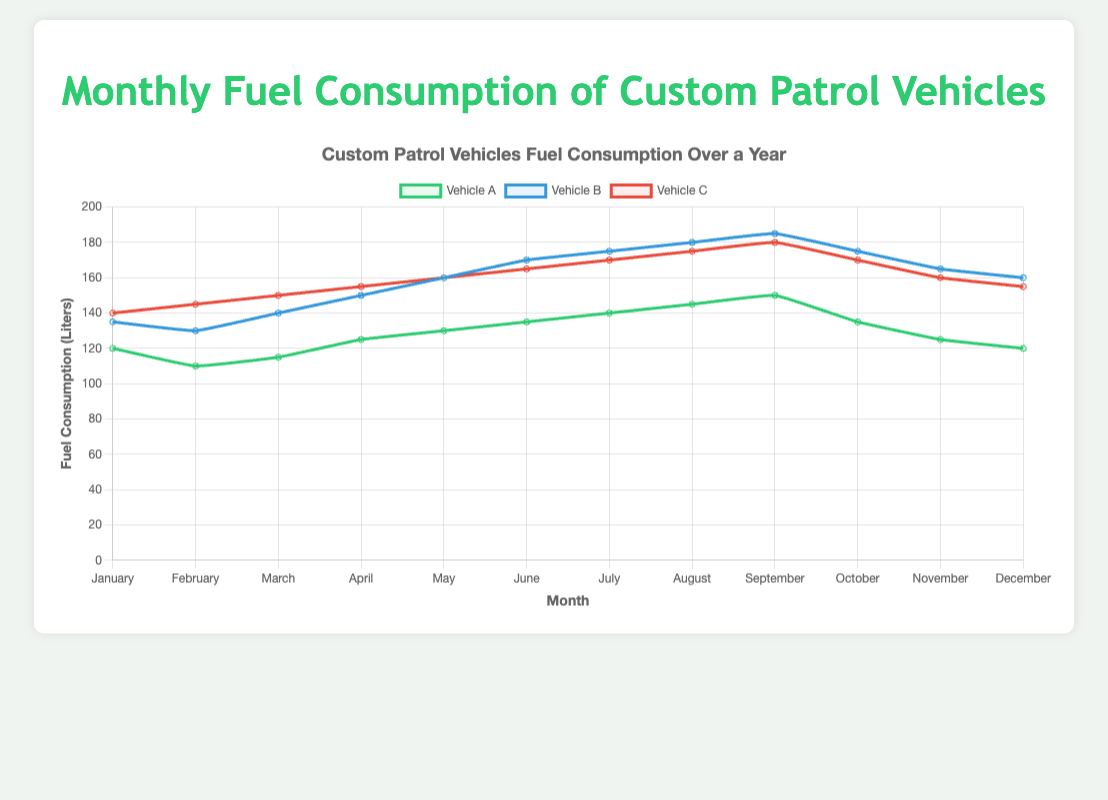What is the average fuel consumption of Vehicle A over the year? To find the average, sum the monthly fuel consumption values for Vehicle A and divide by 12: (120+110+115+125+130+135+140+145+150+135+125+120)/12.
Answer: 128.75 Which vehicle had the highest fuel consumption in August? Look at the data points for August and compare the values for Vehicles A, B, and C. VehicleA: 145, VehicleB: 180, VehicleC: 175.
Answer: Vehicle B Was there a month where all vehicles had the same fuel consumption? The data needs to be examined to see if any month has equal values for Vehicles A, B, and C. There is no month where all three vehicles have the same fuel consumption.
Answer: No In which month did Vehicle B experience the biggest increase in fuel consumption compared to the previous month? Calculate the month-to-month differences in fuel consumption for Vehicle B and find the maximum. Differences: 135-130=5, 140-135=5, 150-140=10, 160-150=10, 170-160=10, 175-170=5, 180-175=5, 185-180=5, 175-185=-10, 165-175=-10, 160-165=-5.
Answer: April to May What is the total fuel consumption for Vehicle C from June to August? Add the fuel consumption values for Vehicle C for the months June, July, and August: 165+170+175.
Answer: 510 In which month were the fuel consumption differences between Vehicle A and Vehicle C the smallest? Calculate the absolute differences for each month and find the smallest value. Differences: 20, 35, 35, 30, 30, 30, 30, 30, 30, 35, 35, 35.
Answer: January How many months did Vehicle A consume more fuel than Vehicle B? Compare monthly values of Vehicle A with Vehicle B to count the instances where Vehicle A consumed more.
Answer: 0 What is the median monthly fuel consumption for Vehicle A? Sort the monthly values for Vehicle A and find the middle value. The sorted values are: 110, 115, 120, 120, 125, 125, 130, 135, 135, 140, 145, 150. The median is the average of the 6th and 7th values: (125+130)/2.
Answer: 127.5 How does the fuel consumption for Vehicle C trend from January to December? Observing the fuel consumption for Vehicle C from January (140) to December (155), we note the general trend, despite fluctuations.
Answer: Increasing What month had the highest aggregated fuel consumption for all vehicles? Sum the fuel consumption of all vehicles for each month and find the maximum value. April: 125+150+155=430, May: 130+160+160=450, June: 135+170+165=470, July: 140+175+170=485, August: 145+180+175=500, September: 150+185+180=515, October: 135+175+170=480, November: 125+165+160=450, December: 120+160+155=435.
Answer: September 